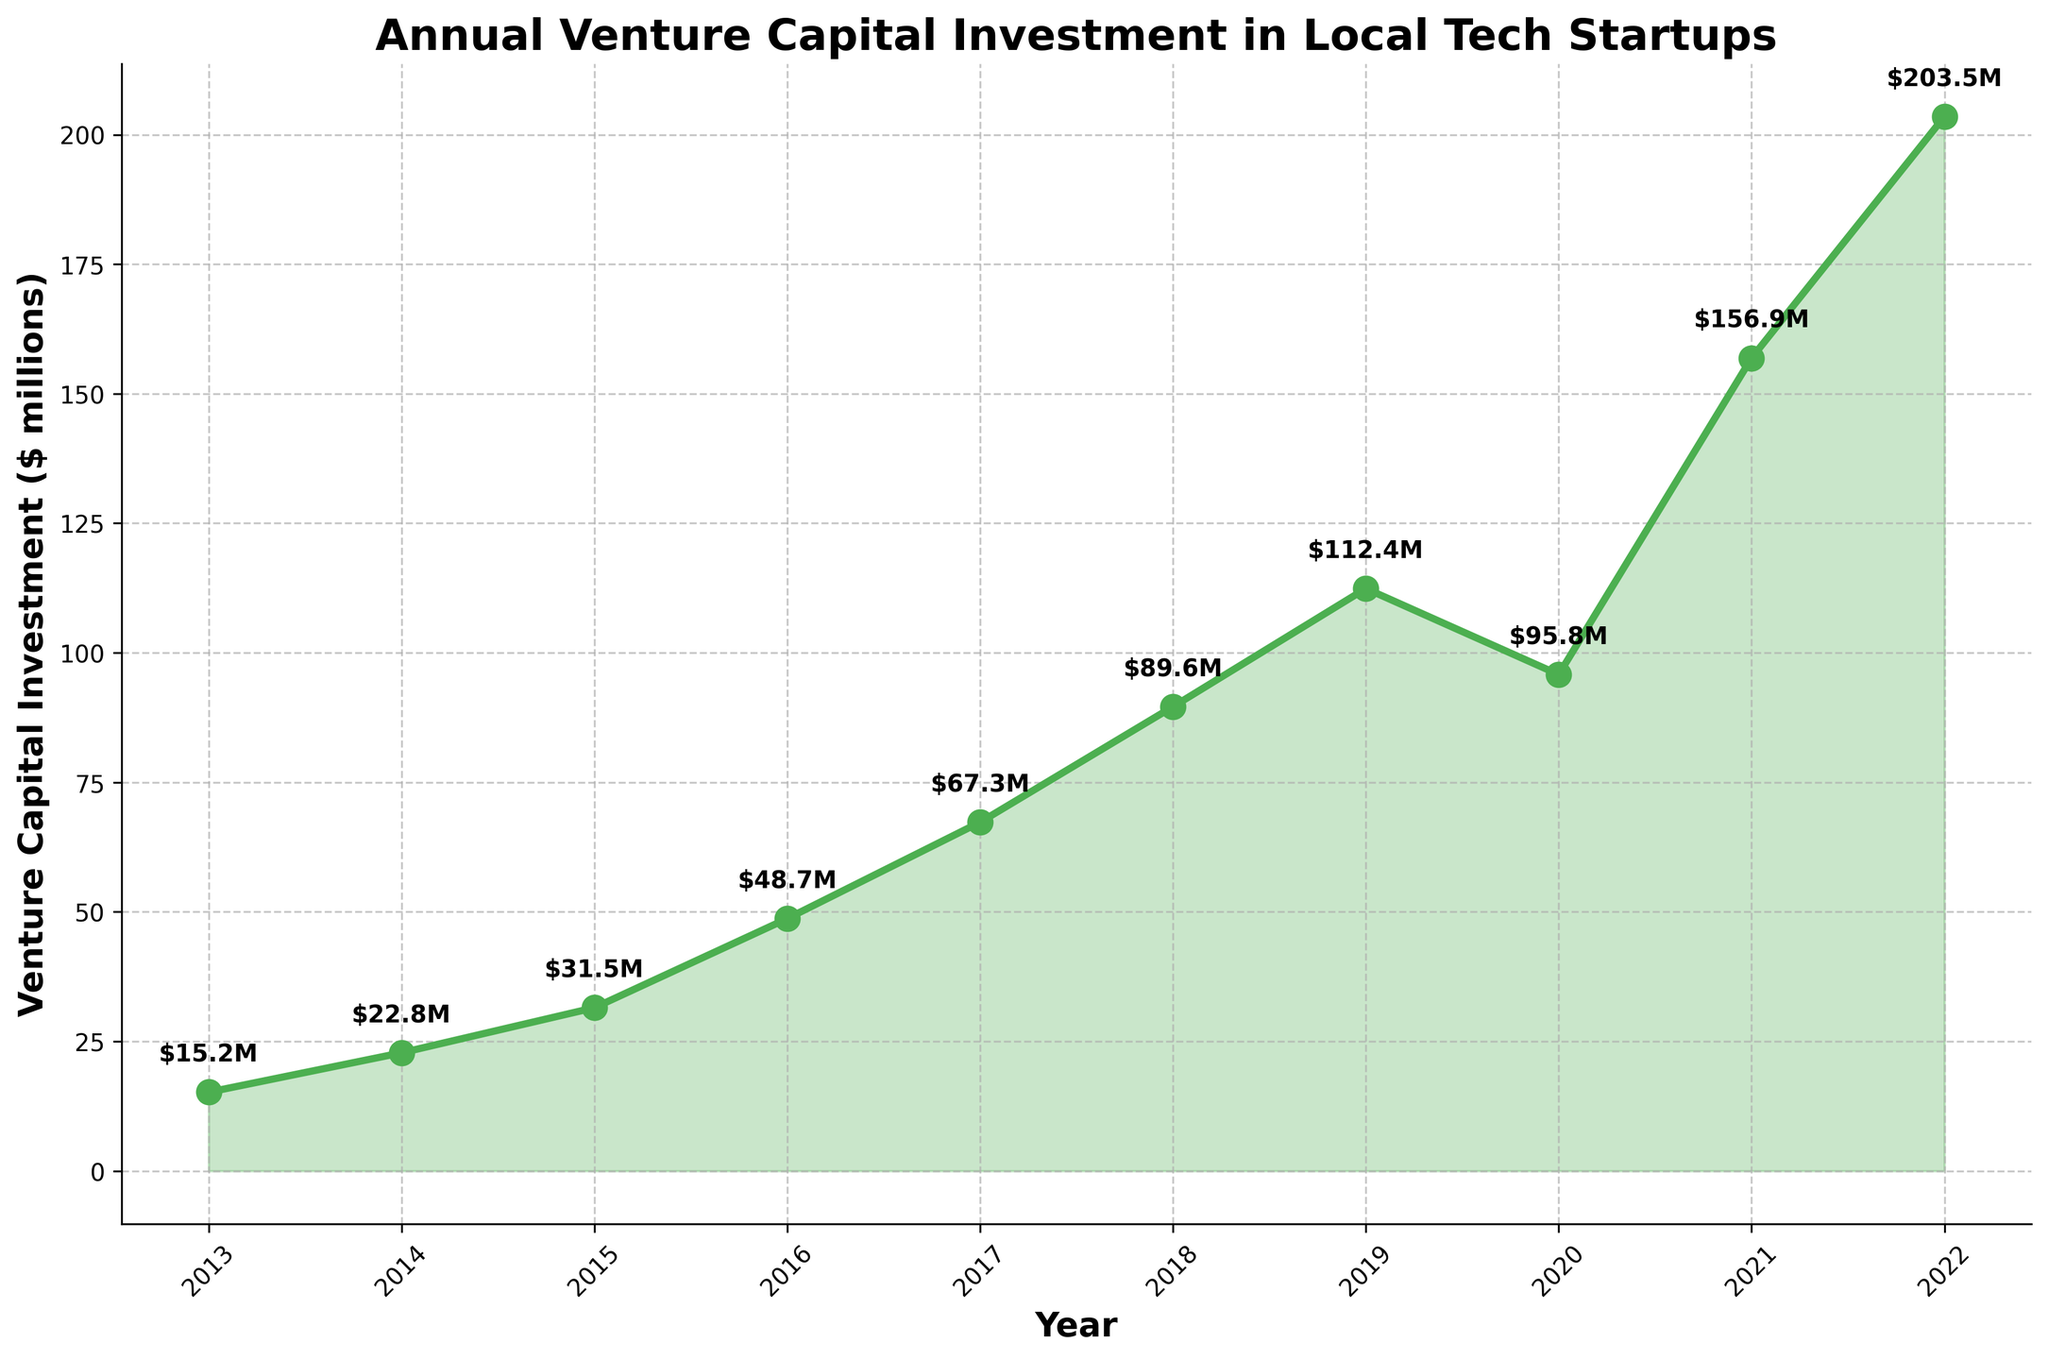What's the total venture capital investment from 2013 to 2017? We add the annual investments for these years: $15.2M (2013) + $22.8M (2014) + $31.5M (2015) + $48.7M (2016) + $67.3M (2017). So, the total is 15.2 + 22.8 + 31.5 + 48.7 + 67.3 = $185.5M
Answer: $185.5M What is the average annual venture capital investment over the entire decade? To calculate the average, sum all the investments and divide by the number of years (10): $(15.2 + 22.8 + 31.5 + 48.7 + 67.3 + 89.6 + 112.4 + 95.8 + 156.9 + 203.5)/10 = 844.7/10 = $84.47M
Answer: $84.47M Which year had the highest venture capital investment? Look at the highest point on the line chart. The highest investment value is in 2022, at $203.5M
Answer: 2022 How does the venture capital investment in 2020 compare to 2019? Compare the investment amounts for these two years: $95.8M (2020) vs $112.4M (2019). 2020 had less investment than 2019 ($95.8M is less than $112.4M)
Answer: 2020 had less investment What is the percentage increase in venture capital investment from 2013 to 2022? Calculate the percentage increase from 2013 ($15.2M) to 2022 ($203.5M). The formula is: ((203.5 - 15.2) / 15.2) * 100 = (188.3 / 15.2) * 100 ≈ 1239.47%
Answer: 1239.47% Which year saw the largest single-year increase in venture capital investment? Look for the biggest difference between consecutive years. The largest increase is from 2021 ($156.9M) to 2022 ($203.5M): 203.5 - 156.9 = $46.6M
Answer: From 2021 to 2022 By how much did the venture capital investment decline from 2021 to 2020? Calculate the difference: $156.9M (2021) - $95.8M (2020) = $61.1M. The investment declined by $61.1M
Answer: $61.1M In which years did the venture capital investment double compared to their previous years? Compare each year's investment with the previous year to find when it doubled. Check 2016 vs 2015: $48.7M is more than double $31.5M; Check 2018 vs 2017: $89.6M is more than double $67.3M
Answer: 2016 and 2018 